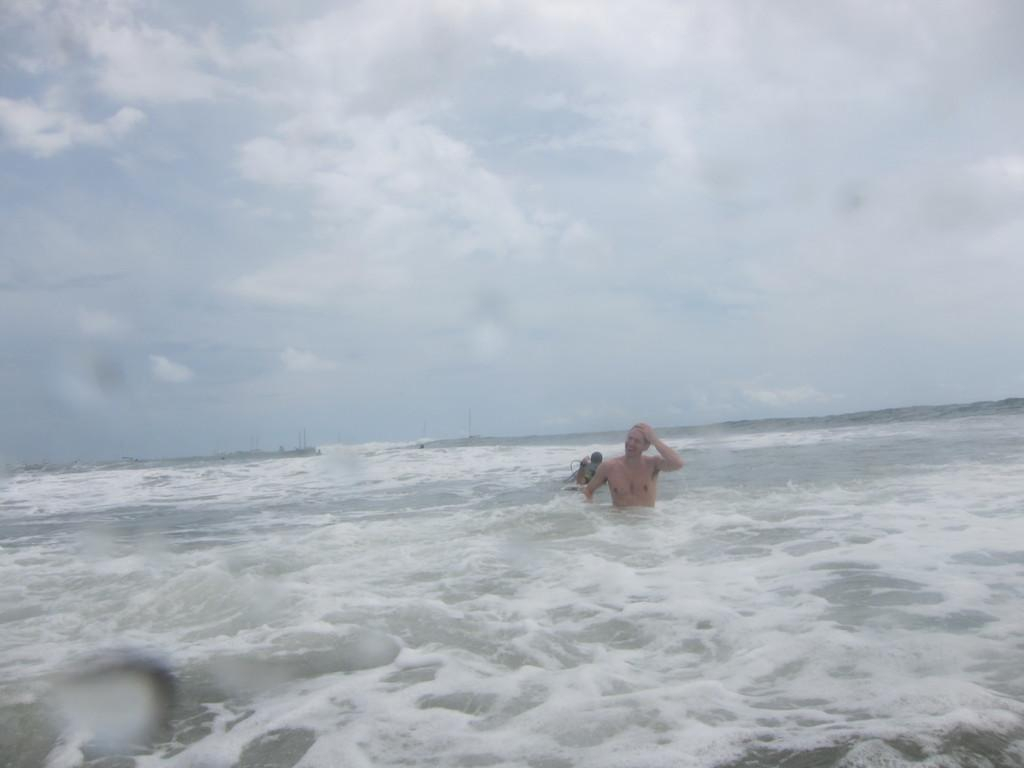How many people are in the water in the image? There are two persons in the water in the image. What can be seen in the background of the image? The sky is visible in the background of the image. What type of cub is visible in the image? There is no cub present in the image. 